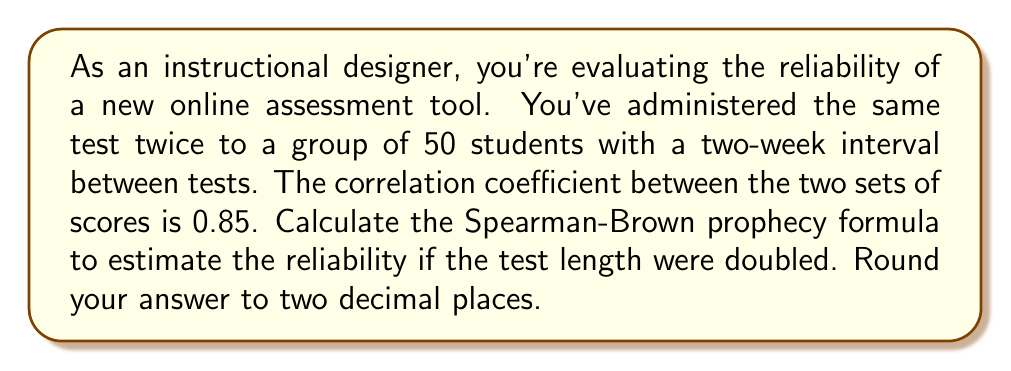Show me your answer to this math problem. To solve this problem, we'll use the Spearman-Brown prophecy formula. This formula is used to estimate the reliability of a test if its length is changed. The formula is:

$$r_{xx'} = \frac{nr_{x,x'}}{1 + (n-1)r_{x,x'}}$$

Where:
$r_{xx'}$ is the predicted reliability
$n$ is the factor by which the test length is changed
$r_{x,x'}$ is the current reliability (correlation coefficient)

Given:
- Current reliability (correlation coefficient) = 0.85
- We want to double the test length, so n = 2

Step 1: Plug the values into the formula
$$r_{xx'} = \frac{2(0.85)}{1 + (2-1)0.85}$$

Step 2: Simplify the numerator
$$r_{xx'} = \frac{1.70}{1 + 0.85}$$

Step 3: Simplify the denominator
$$r_{xx'} = \frac{1.70}{1.85}$$

Step 4: Divide
$$r_{xx'} = 0.9189189189$$

Step 5: Round to two decimal places
$$r_{xx'} = 0.92$$

Therefore, if the test length were doubled, the estimated reliability would be 0.92.
Answer: 0.92 